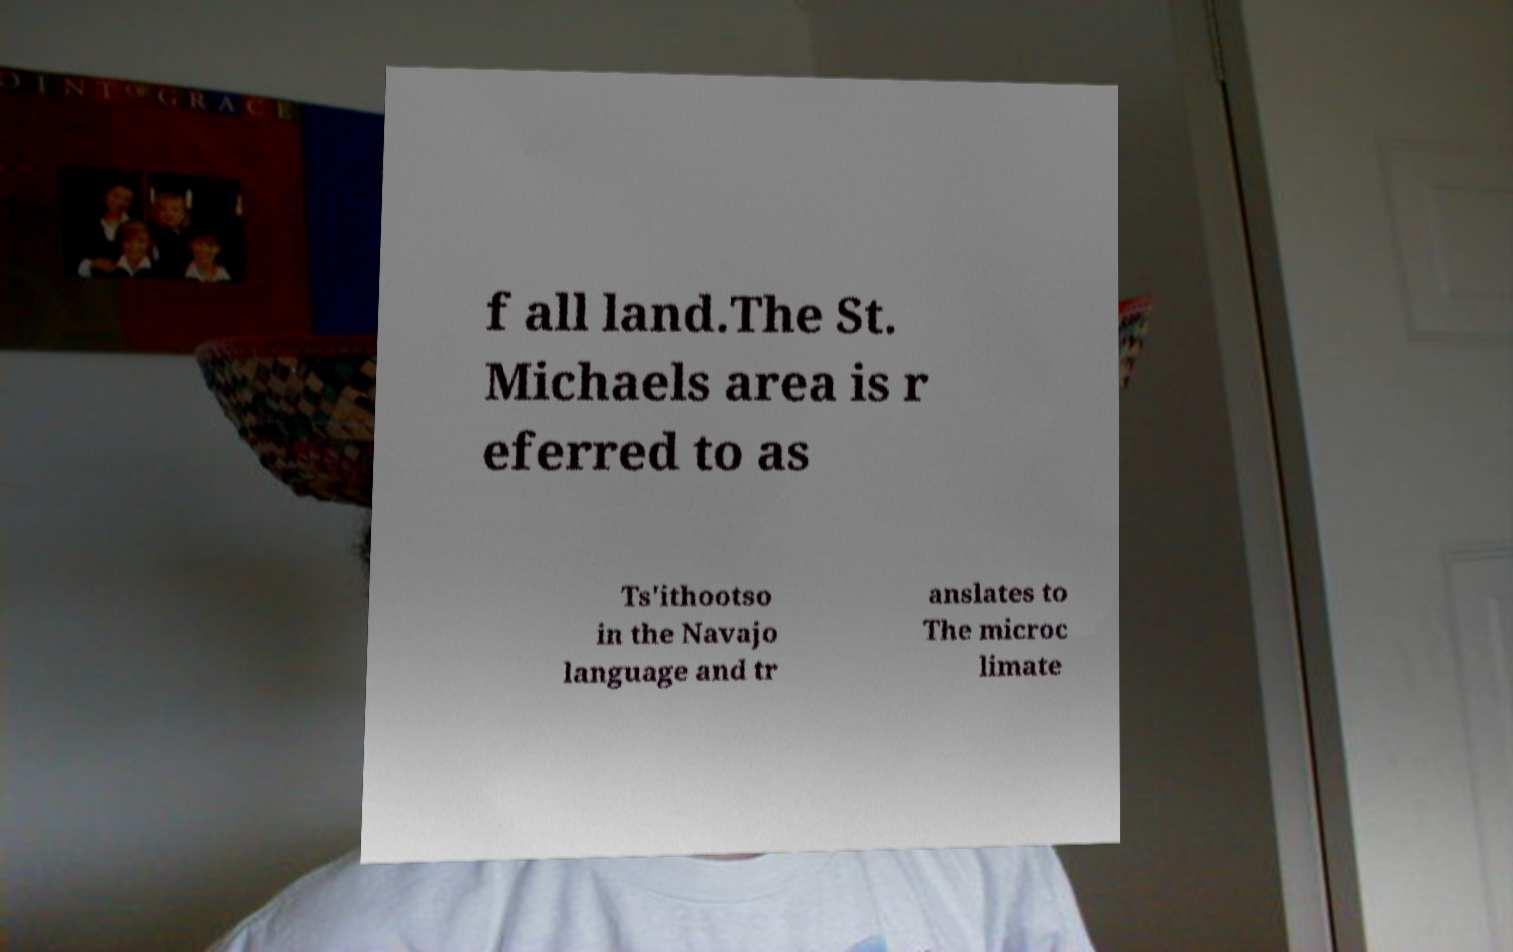Can you accurately transcribe the text from the provided image for me? f all land.The St. Michaels area is r eferred to as Ts'ithootso in the Navajo language and tr anslates to The microc limate 